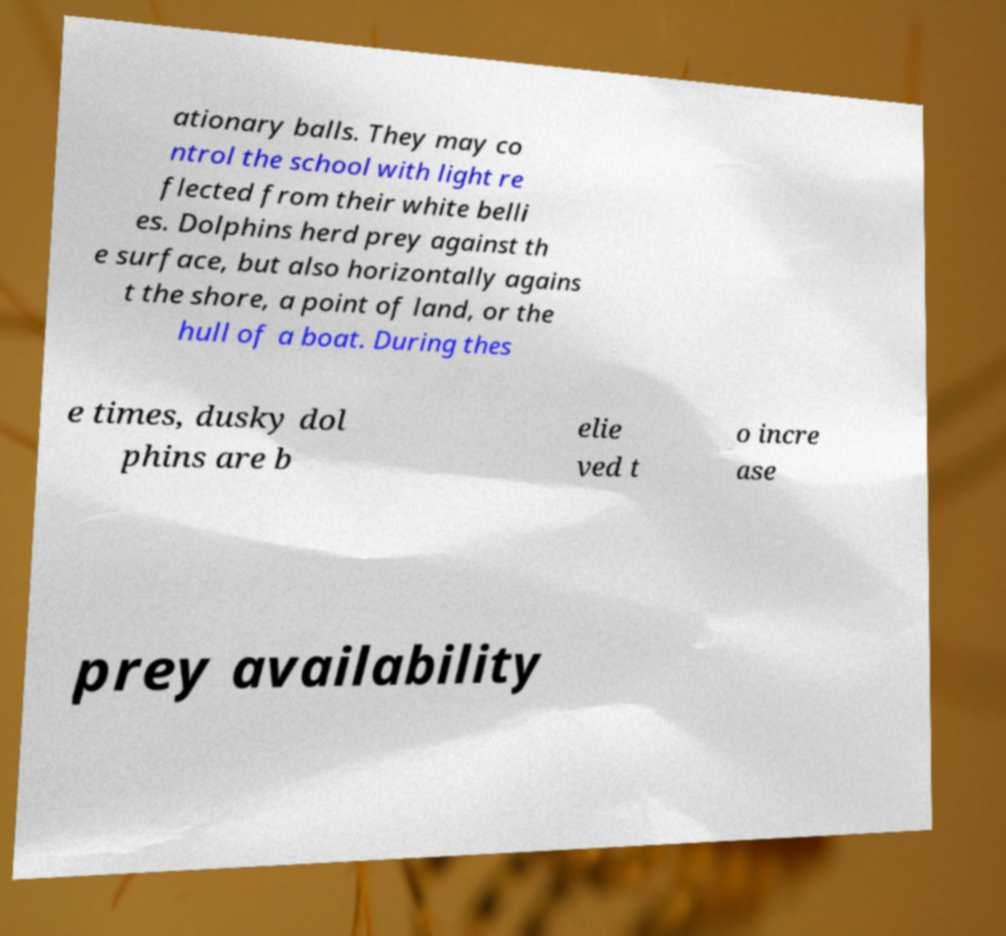Can you read and provide the text displayed in the image?This photo seems to have some interesting text. Can you extract and type it out for me? ationary balls. They may co ntrol the school with light re flected from their white belli es. Dolphins herd prey against th e surface, but also horizontally agains t the shore, a point of land, or the hull of a boat. During thes e times, dusky dol phins are b elie ved t o incre ase prey availability 